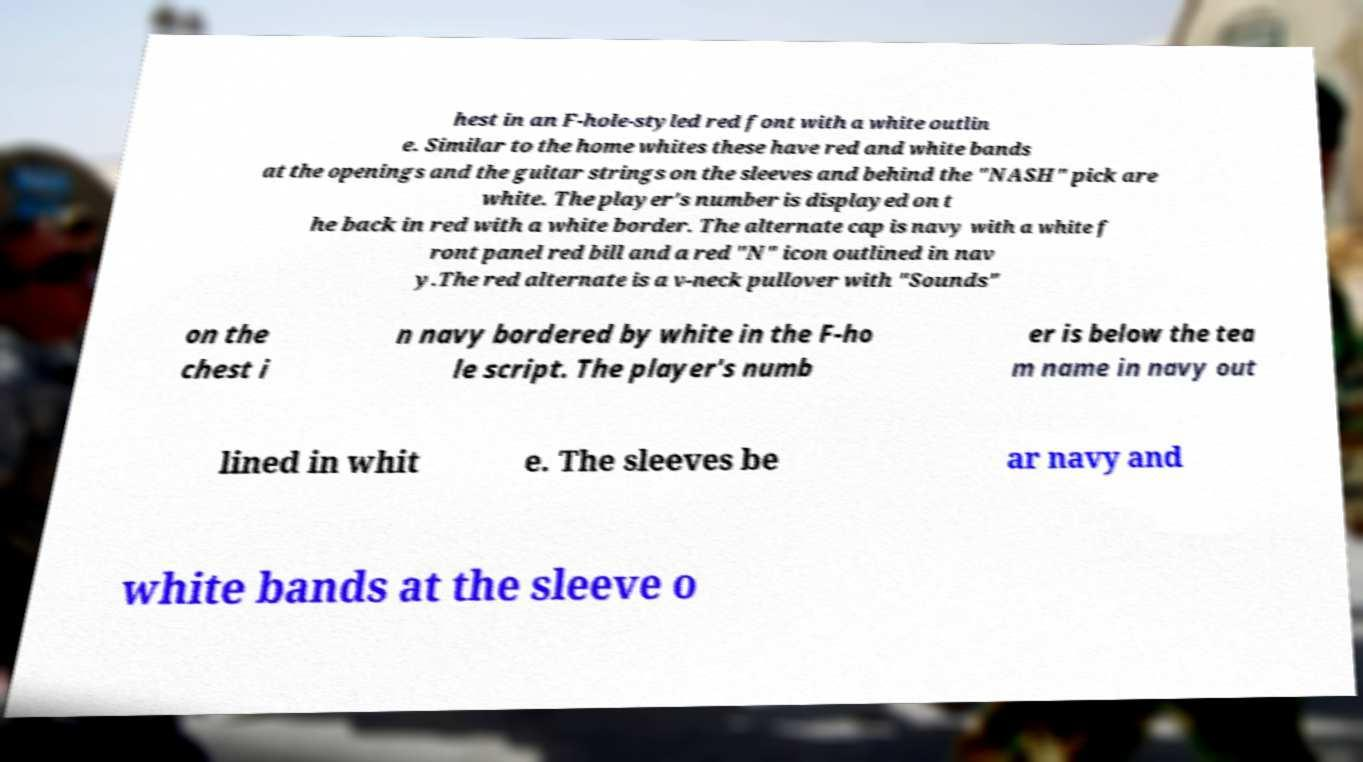Can you accurately transcribe the text from the provided image for me? hest in an F-hole-styled red font with a white outlin e. Similar to the home whites these have red and white bands at the openings and the guitar strings on the sleeves and behind the "NASH" pick are white. The player's number is displayed on t he back in red with a white border. The alternate cap is navy with a white f ront panel red bill and a red "N" icon outlined in nav y.The red alternate is a v-neck pullover with "Sounds" on the chest i n navy bordered by white in the F-ho le script. The player's numb er is below the tea m name in navy out lined in whit e. The sleeves be ar navy and white bands at the sleeve o 